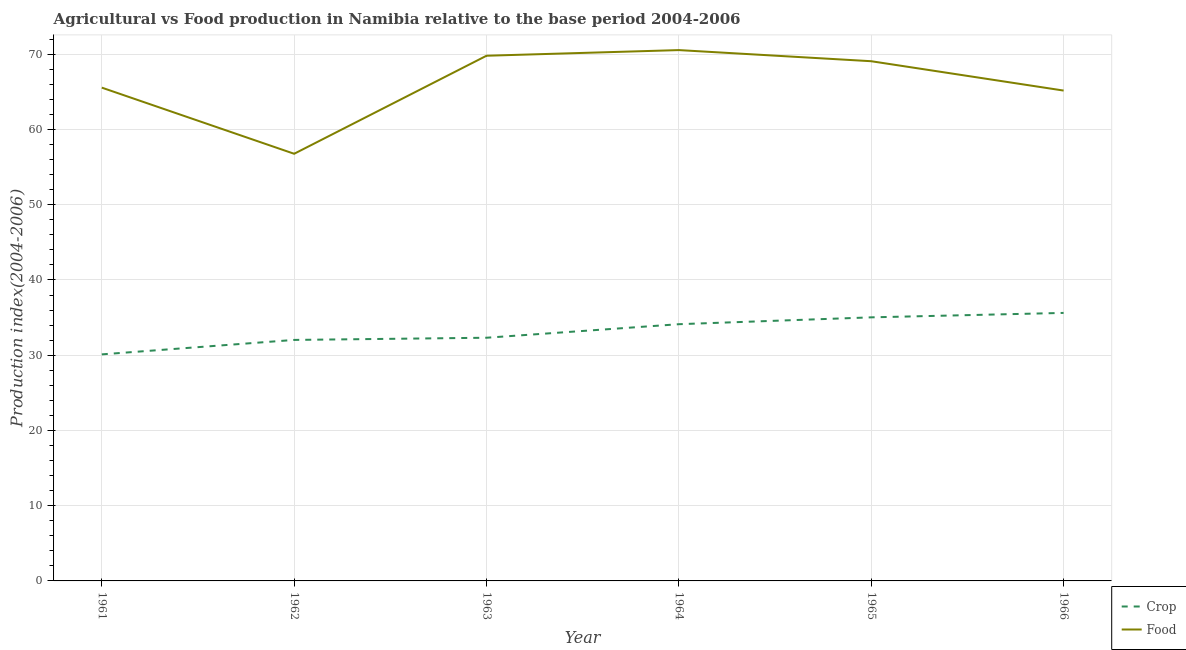How many different coloured lines are there?
Give a very brief answer. 2. Does the line corresponding to food production index intersect with the line corresponding to crop production index?
Your answer should be very brief. No. What is the crop production index in 1963?
Give a very brief answer. 32.32. Across all years, what is the maximum crop production index?
Offer a very short reply. 35.62. Across all years, what is the minimum crop production index?
Ensure brevity in your answer.  30.11. In which year was the crop production index maximum?
Your response must be concise. 1966. What is the total food production index in the graph?
Your answer should be very brief. 396.92. What is the difference between the crop production index in 1961 and that in 1964?
Provide a short and direct response. -4.01. What is the difference between the food production index in 1961 and the crop production index in 1962?
Provide a succinct answer. 33.53. What is the average crop production index per year?
Ensure brevity in your answer.  33.21. In the year 1961, what is the difference between the food production index and crop production index?
Provide a short and direct response. 35.45. What is the ratio of the food production index in 1965 to that in 1966?
Offer a terse response. 1.06. Is the food production index in 1963 less than that in 1965?
Ensure brevity in your answer.  No. Is the difference between the food production index in 1963 and 1966 greater than the difference between the crop production index in 1963 and 1966?
Provide a succinct answer. Yes. What is the difference between the highest and the second highest crop production index?
Your response must be concise. 0.59. What is the difference between the highest and the lowest crop production index?
Offer a very short reply. 5.51. Is the sum of the crop production index in 1963 and 1966 greater than the maximum food production index across all years?
Ensure brevity in your answer.  No. Is the food production index strictly less than the crop production index over the years?
Your answer should be very brief. No. How many lines are there?
Ensure brevity in your answer.  2. How many years are there in the graph?
Your answer should be compact. 6. Where does the legend appear in the graph?
Keep it short and to the point. Bottom right. How are the legend labels stacked?
Ensure brevity in your answer.  Vertical. What is the title of the graph?
Your answer should be compact. Agricultural vs Food production in Namibia relative to the base period 2004-2006. What is the label or title of the X-axis?
Give a very brief answer. Year. What is the label or title of the Y-axis?
Ensure brevity in your answer.  Production index(2004-2006). What is the Production index(2004-2006) in Crop in 1961?
Provide a succinct answer. 30.11. What is the Production index(2004-2006) of Food in 1961?
Ensure brevity in your answer.  65.56. What is the Production index(2004-2006) in Crop in 1962?
Provide a short and direct response. 32.03. What is the Production index(2004-2006) in Food in 1962?
Make the answer very short. 56.77. What is the Production index(2004-2006) of Crop in 1963?
Offer a very short reply. 32.32. What is the Production index(2004-2006) in Food in 1963?
Your answer should be very brief. 69.8. What is the Production index(2004-2006) of Crop in 1964?
Ensure brevity in your answer.  34.12. What is the Production index(2004-2006) in Food in 1964?
Offer a terse response. 70.55. What is the Production index(2004-2006) in Crop in 1965?
Your answer should be compact. 35.03. What is the Production index(2004-2006) of Food in 1965?
Make the answer very short. 69.07. What is the Production index(2004-2006) in Crop in 1966?
Give a very brief answer. 35.62. What is the Production index(2004-2006) of Food in 1966?
Provide a succinct answer. 65.17. Across all years, what is the maximum Production index(2004-2006) in Crop?
Your answer should be compact. 35.62. Across all years, what is the maximum Production index(2004-2006) of Food?
Make the answer very short. 70.55. Across all years, what is the minimum Production index(2004-2006) in Crop?
Give a very brief answer. 30.11. Across all years, what is the minimum Production index(2004-2006) of Food?
Make the answer very short. 56.77. What is the total Production index(2004-2006) in Crop in the graph?
Provide a succinct answer. 199.23. What is the total Production index(2004-2006) of Food in the graph?
Offer a very short reply. 396.92. What is the difference between the Production index(2004-2006) in Crop in 1961 and that in 1962?
Give a very brief answer. -1.92. What is the difference between the Production index(2004-2006) in Food in 1961 and that in 1962?
Your answer should be very brief. 8.79. What is the difference between the Production index(2004-2006) of Crop in 1961 and that in 1963?
Your response must be concise. -2.21. What is the difference between the Production index(2004-2006) in Food in 1961 and that in 1963?
Provide a succinct answer. -4.24. What is the difference between the Production index(2004-2006) of Crop in 1961 and that in 1964?
Your response must be concise. -4.01. What is the difference between the Production index(2004-2006) in Food in 1961 and that in 1964?
Offer a terse response. -4.99. What is the difference between the Production index(2004-2006) of Crop in 1961 and that in 1965?
Offer a terse response. -4.92. What is the difference between the Production index(2004-2006) in Food in 1961 and that in 1965?
Provide a succinct answer. -3.51. What is the difference between the Production index(2004-2006) of Crop in 1961 and that in 1966?
Give a very brief answer. -5.51. What is the difference between the Production index(2004-2006) in Food in 1961 and that in 1966?
Give a very brief answer. 0.39. What is the difference between the Production index(2004-2006) in Crop in 1962 and that in 1963?
Your answer should be compact. -0.29. What is the difference between the Production index(2004-2006) of Food in 1962 and that in 1963?
Your response must be concise. -13.03. What is the difference between the Production index(2004-2006) of Crop in 1962 and that in 1964?
Your answer should be compact. -2.09. What is the difference between the Production index(2004-2006) in Food in 1962 and that in 1964?
Your answer should be compact. -13.78. What is the difference between the Production index(2004-2006) of Crop in 1962 and that in 1966?
Your answer should be compact. -3.59. What is the difference between the Production index(2004-2006) in Crop in 1963 and that in 1964?
Offer a terse response. -1.8. What is the difference between the Production index(2004-2006) in Food in 1963 and that in 1964?
Ensure brevity in your answer.  -0.75. What is the difference between the Production index(2004-2006) of Crop in 1963 and that in 1965?
Ensure brevity in your answer.  -2.71. What is the difference between the Production index(2004-2006) of Food in 1963 and that in 1965?
Provide a succinct answer. 0.73. What is the difference between the Production index(2004-2006) of Food in 1963 and that in 1966?
Offer a very short reply. 4.63. What is the difference between the Production index(2004-2006) of Crop in 1964 and that in 1965?
Your answer should be compact. -0.91. What is the difference between the Production index(2004-2006) in Food in 1964 and that in 1965?
Make the answer very short. 1.48. What is the difference between the Production index(2004-2006) in Food in 1964 and that in 1966?
Your response must be concise. 5.38. What is the difference between the Production index(2004-2006) of Crop in 1965 and that in 1966?
Offer a very short reply. -0.59. What is the difference between the Production index(2004-2006) in Food in 1965 and that in 1966?
Offer a terse response. 3.9. What is the difference between the Production index(2004-2006) in Crop in 1961 and the Production index(2004-2006) in Food in 1962?
Your response must be concise. -26.66. What is the difference between the Production index(2004-2006) in Crop in 1961 and the Production index(2004-2006) in Food in 1963?
Offer a terse response. -39.69. What is the difference between the Production index(2004-2006) of Crop in 1961 and the Production index(2004-2006) of Food in 1964?
Keep it short and to the point. -40.44. What is the difference between the Production index(2004-2006) of Crop in 1961 and the Production index(2004-2006) of Food in 1965?
Your response must be concise. -38.96. What is the difference between the Production index(2004-2006) of Crop in 1961 and the Production index(2004-2006) of Food in 1966?
Offer a terse response. -35.06. What is the difference between the Production index(2004-2006) of Crop in 1962 and the Production index(2004-2006) of Food in 1963?
Your answer should be very brief. -37.77. What is the difference between the Production index(2004-2006) in Crop in 1962 and the Production index(2004-2006) in Food in 1964?
Your answer should be compact. -38.52. What is the difference between the Production index(2004-2006) of Crop in 1962 and the Production index(2004-2006) of Food in 1965?
Offer a terse response. -37.04. What is the difference between the Production index(2004-2006) in Crop in 1962 and the Production index(2004-2006) in Food in 1966?
Offer a very short reply. -33.14. What is the difference between the Production index(2004-2006) in Crop in 1963 and the Production index(2004-2006) in Food in 1964?
Provide a succinct answer. -38.23. What is the difference between the Production index(2004-2006) in Crop in 1963 and the Production index(2004-2006) in Food in 1965?
Your answer should be compact. -36.75. What is the difference between the Production index(2004-2006) in Crop in 1963 and the Production index(2004-2006) in Food in 1966?
Make the answer very short. -32.85. What is the difference between the Production index(2004-2006) in Crop in 1964 and the Production index(2004-2006) in Food in 1965?
Your answer should be compact. -34.95. What is the difference between the Production index(2004-2006) in Crop in 1964 and the Production index(2004-2006) in Food in 1966?
Make the answer very short. -31.05. What is the difference between the Production index(2004-2006) of Crop in 1965 and the Production index(2004-2006) of Food in 1966?
Give a very brief answer. -30.14. What is the average Production index(2004-2006) in Crop per year?
Ensure brevity in your answer.  33.2. What is the average Production index(2004-2006) in Food per year?
Make the answer very short. 66.15. In the year 1961, what is the difference between the Production index(2004-2006) of Crop and Production index(2004-2006) of Food?
Your answer should be very brief. -35.45. In the year 1962, what is the difference between the Production index(2004-2006) in Crop and Production index(2004-2006) in Food?
Provide a succinct answer. -24.74. In the year 1963, what is the difference between the Production index(2004-2006) of Crop and Production index(2004-2006) of Food?
Your answer should be compact. -37.48. In the year 1964, what is the difference between the Production index(2004-2006) in Crop and Production index(2004-2006) in Food?
Your answer should be compact. -36.43. In the year 1965, what is the difference between the Production index(2004-2006) of Crop and Production index(2004-2006) of Food?
Ensure brevity in your answer.  -34.04. In the year 1966, what is the difference between the Production index(2004-2006) of Crop and Production index(2004-2006) of Food?
Make the answer very short. -29.55. What is the ratio of the Production index(2004-2006) of Crop in 1961 to that in 1962?
Ensure brevity in your answer.  0.94. What is the ratio of the Production index(2004-2006) in Food in 1961 to that in 1962?
Offer a very short reply. 1.15. What is the ratio of the Production index(2004-2006) of Crop in 1961 to that in 1963?
Your answer should be compact. 0.93. What is the ratio of the Production index(2004-2006) in Food in 1961 to that in 1963?
Keep it short and to the point. 0.94. What is the ratio of the Production index(2004-2006) in Crop in 1961 to that in 1964?
Give a very brief answer. 0.88. What is the ratio of the Production index(2004-2006) of Food in 1961 to that in 1964?
Ensure brevity in your answer.  0.93. What is the ratio of the Production index(2004-2006) of Crop in 1961 to that in 1965?
Offer a terse response. 0.86. What is the ratio of the Production index(2004-2006) in Food in 1961 to that in 1965?
Offer a terse response. 0.95. What is the ratio of the Production index(2004-2006) in Crop in 1961 to that in 1966?
Ensure brevity in your answer.  0.85. What is the ratio of the Production index(2004-2006) in Food in 1961 to that in 1966?
Your answer should be compact. 1.01. What is the ratio of the Production index(2004-2006) in Crop in 1962 to that in 1963?
Give a very brief answer. 0.99. What is the ratio of the Production index(2004-2006) in Food in 1962 to that in 1963?
Give a very brief answer. 0.81. What is the ratio of the Production index(2004-2006) of Crop in 1962 to that in 1964?
Your answer should be compact. 0.94. What is the ratio of the Production index(2004-2006) in Food in 1962 to that in 1964?
Make the answer very short. 0.8. What is the ratio of the Production index(2004-2006) in Crop in 1962 to that in 1965?
Keep it short and to the point. 0.91. What is the ratio of the Production index(2004-2006) of Food in 1962 to that in 1965?
Offer a very short reply. 0.82. What is the ratio of the Production index(2004-2006) of Crop in 1962 to that in 1966?
Offer a terse response. 0.9. What is the ratio of the Production index(2004-2006) in Food in 1962 to that in 1966?
Your response must be concise. 0.87. What is the ratio of the Production index(2004-2006) in Crop in 1963 to that in 1964?
Offer a very short reply. 0.95. What is the ratio of the Production index(2004-2006) in Crop in 1963 to that in 1965?
Make the answer very short. 0.92. What is the ratio of the Production index(2004-2006) in Food in 1963 to that in 1965?
Give a very brief answer. 1.01. What is the ratio of the Production index(2004-2006) of Crop in 1963 to that in 1966?
Give a very brief answer. 0.91. What is the ratio of the Production index(2004-2006) in Food in 1963 to that in 1966?
Your answer should be very brief. 1.07. What is the ratio of the Production index(2004-2006) in Crop in 1964 to that in 1965?
Offer a terse response. 0.97. What is the ratio of the Production index(2004-2006) of Food in 1964 to that in 1965?
Offer a very short reply. 1.02. What is the ratio of the Production index(2004-2006) in Crop in 1964 to that in 1966?
Your response must be concise. 0.96. What is the ratio of the Production index(2004-2006) in Food in 1964 to that in 1966?
Make the answer very short. 1.08. What is the ratio of the Production index(2004-2006) in Crop in 1965 to that in 1966?
Give a very brief answer. 0.98. What is the ratio of the Production index(2004-2006) in Food in 1965 to that in 1966?
Offer a terse response. 1.06. What is the difference between the highest and the second highest Production index(2004-2006) of Crop?
Offer a very short reply. 0.59. What is the difference between the highest and the lowest Production index(2004-2006) of Crop?
Your answer should be compact. 5.51. What is the difference between the highest and the lowest Production index(2004-2006) in Food?
Keep it short and to the point. 13.78. 